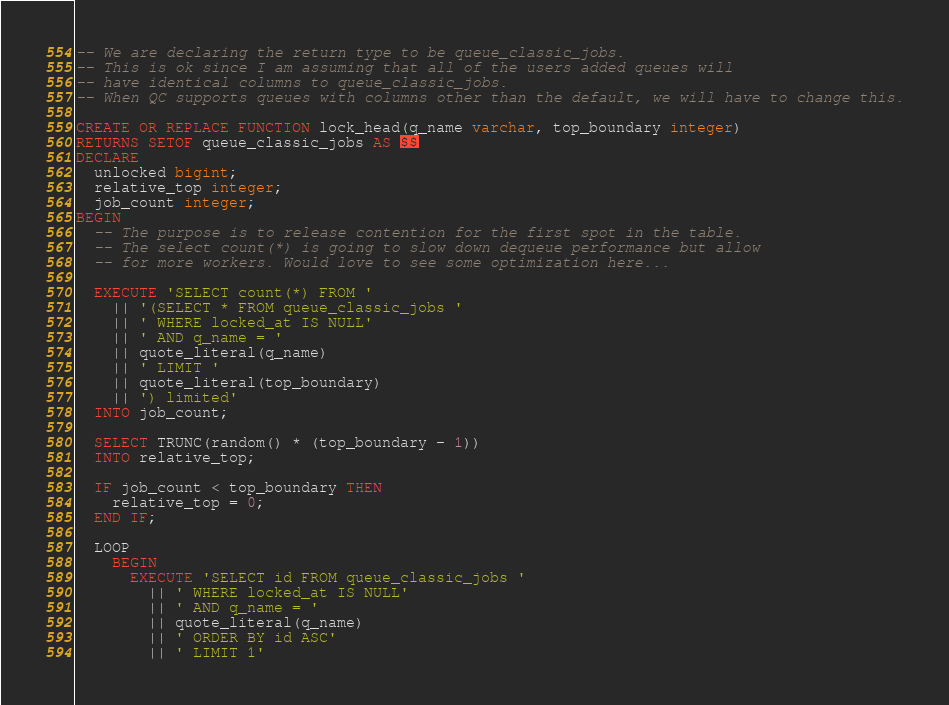Convert code to text. <code><loc_0><loc_0><loc_500><loc_500><_SQL_>-- We are declaring the return type to be queue_classic_jobs.
-- This is ok since I am assuming that all of the users added queues will
-- have identical columns to queue_classic_jobs.
-- When QC supports queues with columns other than the default, we will have to change this.

CREATE OR REPLACE FUNCTION lock_head(q_name varchar, top_boundary integer)
RETURNS SETOF queue_classic_jobs AS $$
DECLARE
  unlocked bigint;
  relative_top integer;
  job_count integer;
BEGIN
  -- The purpose is to release contention for the first spot in the table.
  -- The select count(*) is going to slow down dequeue performance but allow
  -- for more workers. Would love to see some optimization here...

  EXECUTE 'SELECT count(*) FROM '
    || '(SELECT * FROM queue_classic_jobs '
    || ' WHERE locked_at IS NULL'
    || ' AND q_name = '
    || quote_literal(q_name)
    || ' LIMIT '
    || quote_literal(top_boundary)
    || ') limited'
  INTO job_count;

  SELECT TRUNC(random() * (top_boundary - 1))
  INTO relative_top;

  IF job_count < top_boundary THEN
    relative_top = 0;
  END IF;

  LOOP
    BEGIN
      EXECUTE 'SELECT id FROM queue_classic_jobs '
        || ' WHERE locked_at IS NULL'
        || ' AND q_name = '
        || quote_literal(q_name)
        || ' ORDER BY id ASC'
        || ' LIMIT 1'</code> 